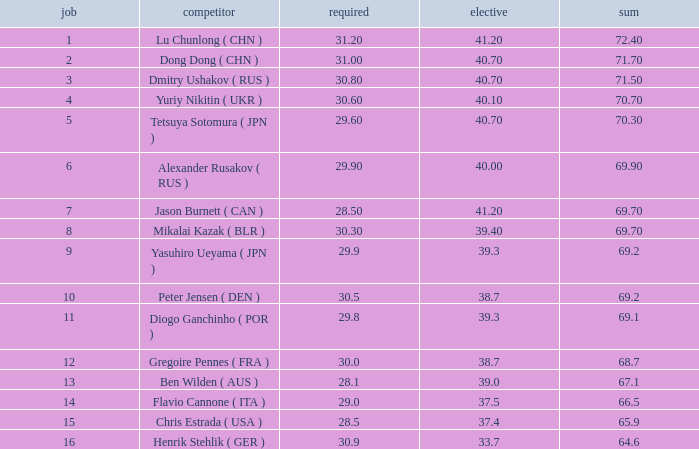What's the total compulsory when the total is more than 69.2 and the voluntary is 38.7? 0.0. 